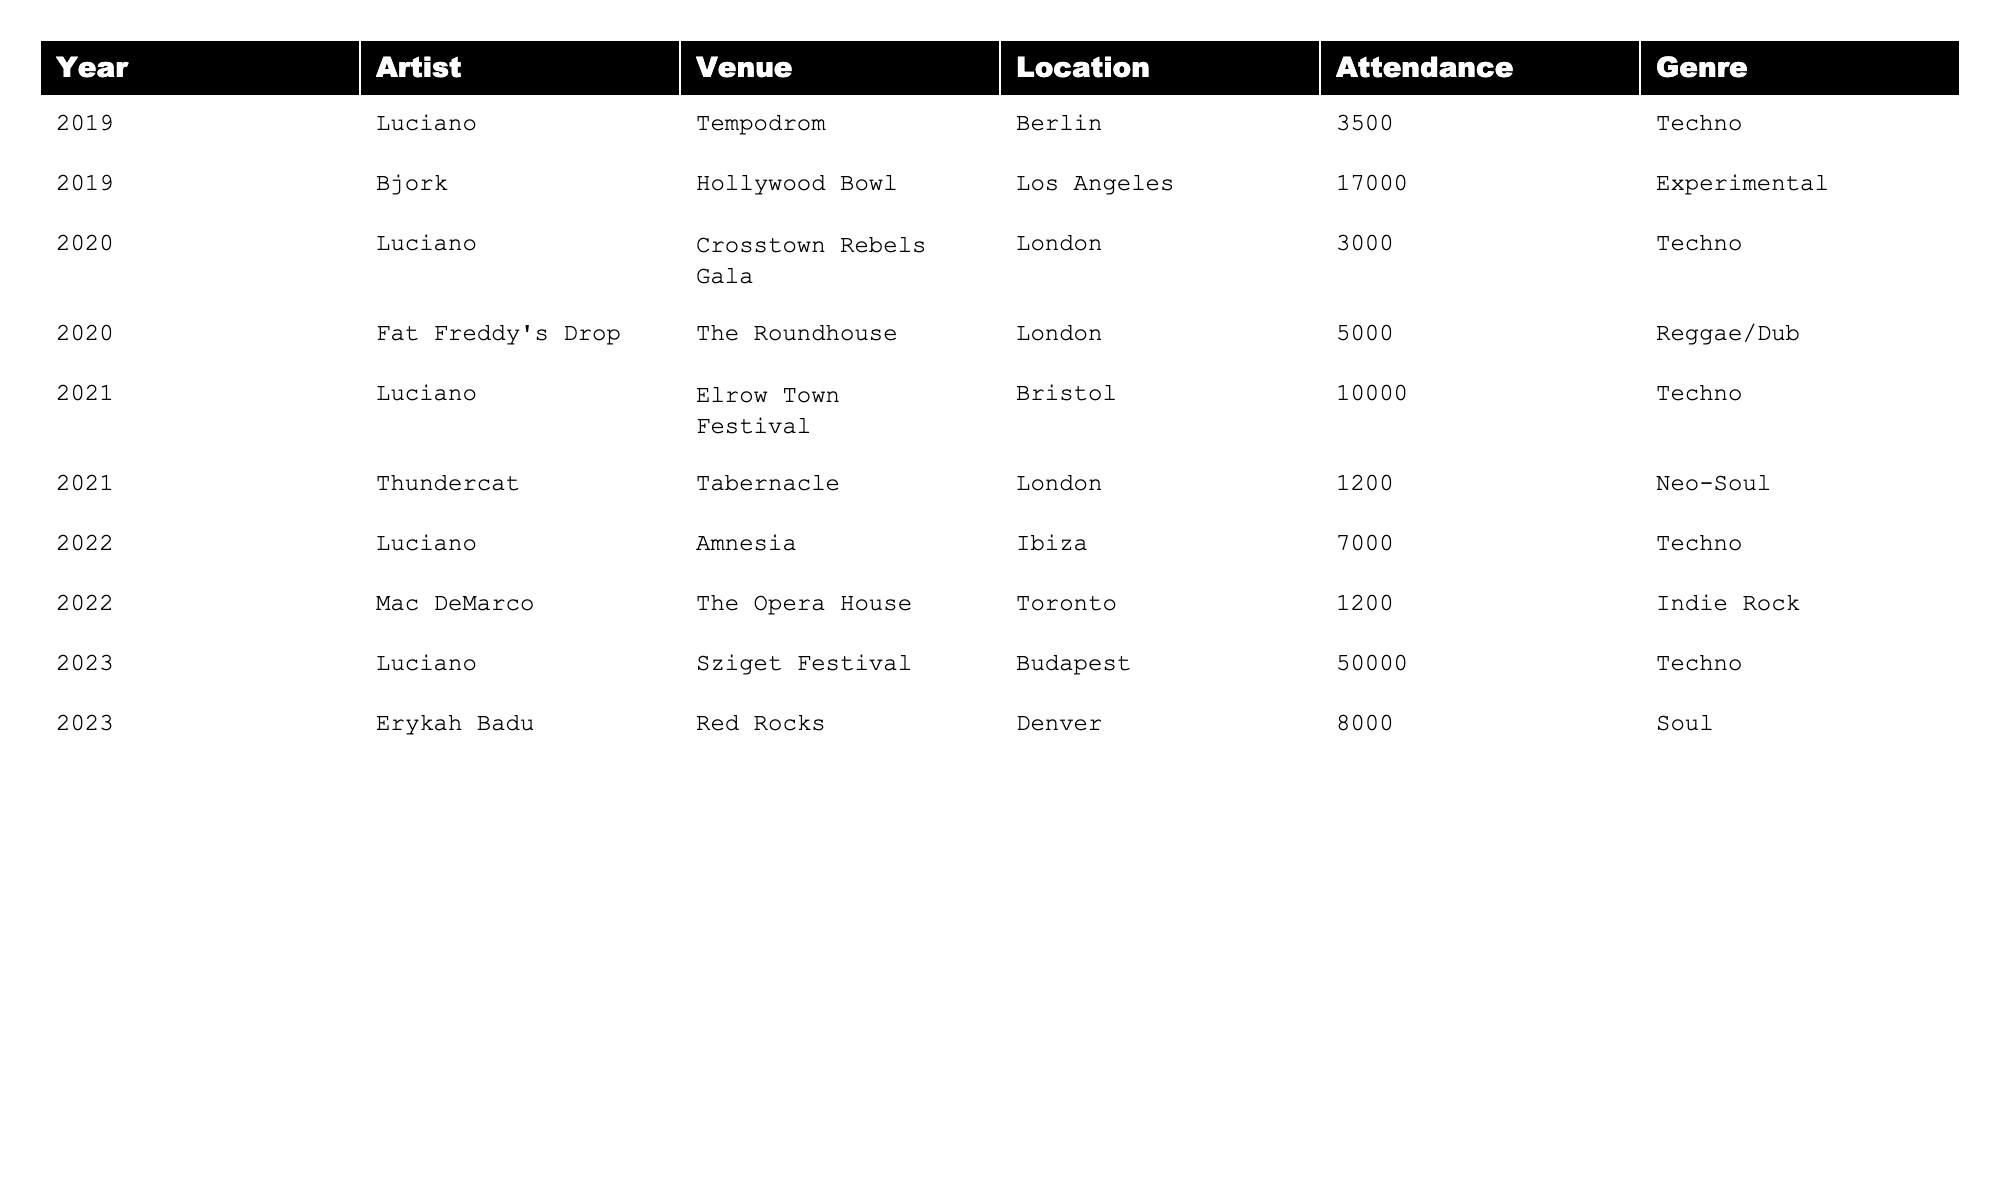What was the highest concert attendance for Luciano in the past 5 years? In 2023, Luciano had the highest attendance at Sziget Festival with 50,000 attendees.
Answer: 50,000 Which artist had the lowest attendance in 2021? In 2021, Thundercat had the lowest attendance with 1,200 attendees at the Tabernacle in London.
Answer: 1,200 What was the total attendance for all Luciano concerts over the 5 years? To find the total attendance for Luciano concerts, we sum the attendance figures: 3500 + 3000 + 10000 + 7000 + 50000 = 61000.
Answer: 61,000 Did Bjork perform at a venue with more than 15,000 attendees? Yes, Bjork performed at the Hollywood Bowl, which had an attendance of 17,000.
Answer: Yes Which year saw the greatest total attendance across all artists? First, we calculate the total attendance for each year: 2019 (3500 + 17000 = 20500), 2020 (3000 + 5000 = 8000), 2021 (10000 + 1200 = 11200), 2022 (7000 + 1200 = 8200), 2023 (50000 + 8000 = 58000). The highest total is for 2023 with 58,000 attendees.
Answer: 2023 What genre had the highest attendance at a concert in 2022? In 2022, Luciano's Techno concert at Amnesia had 7,000 attendees, while Mac DeMarco's Indie Rock concert had 1,200. The highest attendance was for Techno.
Answer: Techno How many years did Luciano perform at a venue with an attendance of over 10,000? Luciano performed at venues with over 10,000 attendees in 2021 (10,000) and 2023 (50,000), which are two years.
Answer: 2 Were there any concerts with attendance above 5,000 in 2020? No, the maximum attendance for 2020 was 5,000 by Fat Freddy's Drop, so there were no concerts above 5,000.
Answer: No 